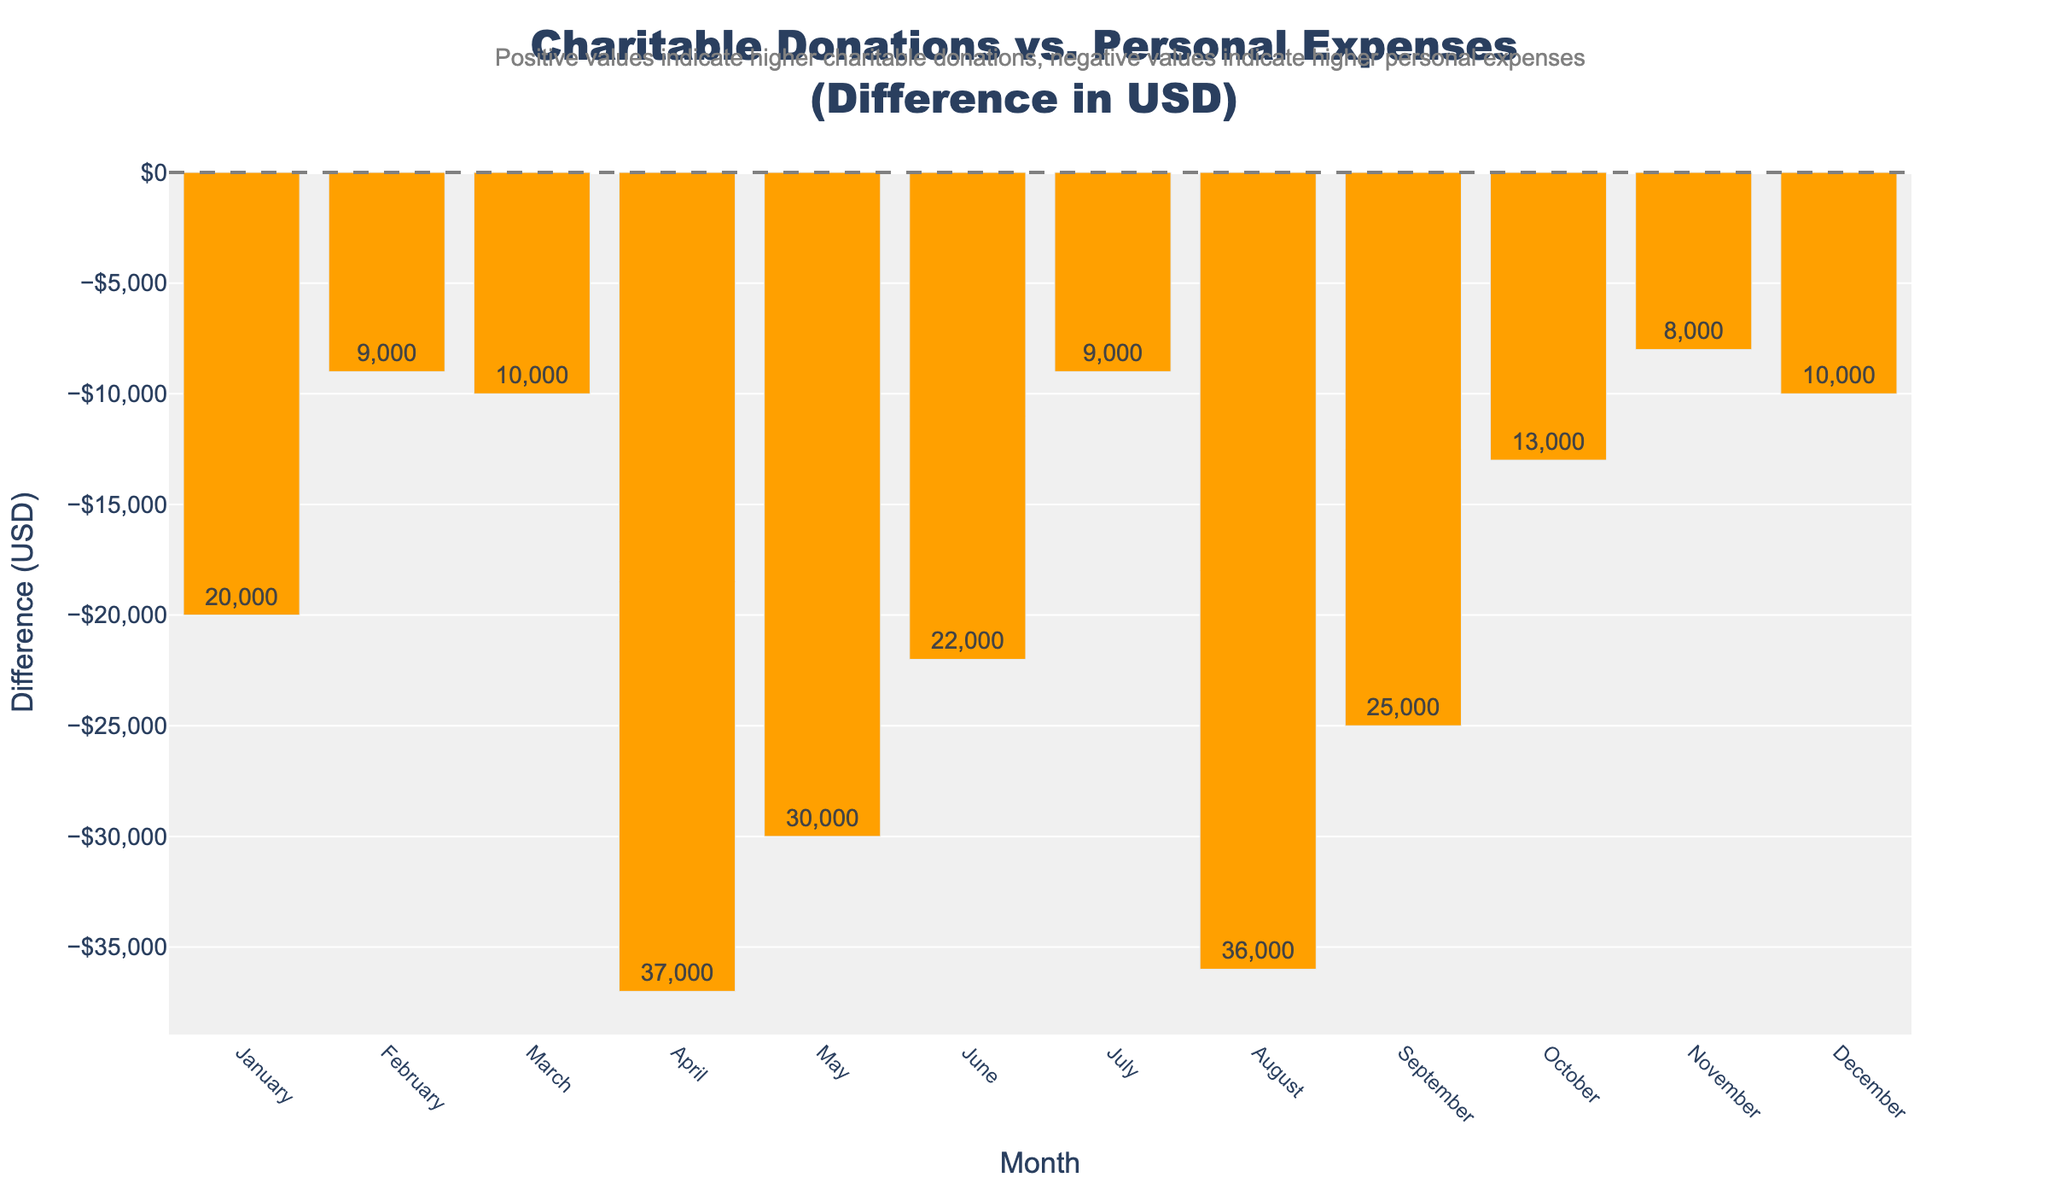Which month had the highest difference, and was it positive or negative? To find the month with the highest difference, look for the tallest bar on the diverging bar chart. The color indicates whether it is positive (higher donations) or negative (higher expenses).
Answer: December, positive Which month had personal expenses higher than donations by the largest amount? Look for the month with the tallest bar extending into the negative area (colored orange). This indicates the largest difference where expenses exceed donations.
Answer: August What was the average difference between charitable donations and personal expenses over the year? Sum all the differences and divide by 12. The differences are calculated by subtracting personal expenses from charitable donations for each month.
Answer: -$5,083.33 During which months were charitable donations higher than personal expenses? Identify the months with bars above the zero line (colored blue), indicating positive differences.
Answer: January, February, March, May, June, July, October, November, December How many months had charitable donations higher than $60,000? Count the bars corresponding to months where the charitable donations exceed $60,000. These months are evident from the hover information showing the donations.
Answer: 5 For which months did the difference hover around zero (±$5,000)? Look for bars whose length falls within the $5,000 range on either side of the zero line.
Answer: February, May, July, October What was the combined total of personal expenses for April and May? Add the personal expenses of April and May as shown in the hover information for those months.
Answer: $161,000 Which month had the smallest positive difference where donations were higher than expenses? Among the blue bars, find the one with the smallest height, indicating the smallest positive difference.
Answer: May What is the sum of the differences for months where expenses exceeded donations? Summing the values of the negative differences (orange bars) gives the total shortfall where expenses were higher.
Answer: -$115,000 Which month had the lowest amount for charitable donations? Identify the month with the lowest value for charitable donations, available from the hover information for each bar.
Answer: April 